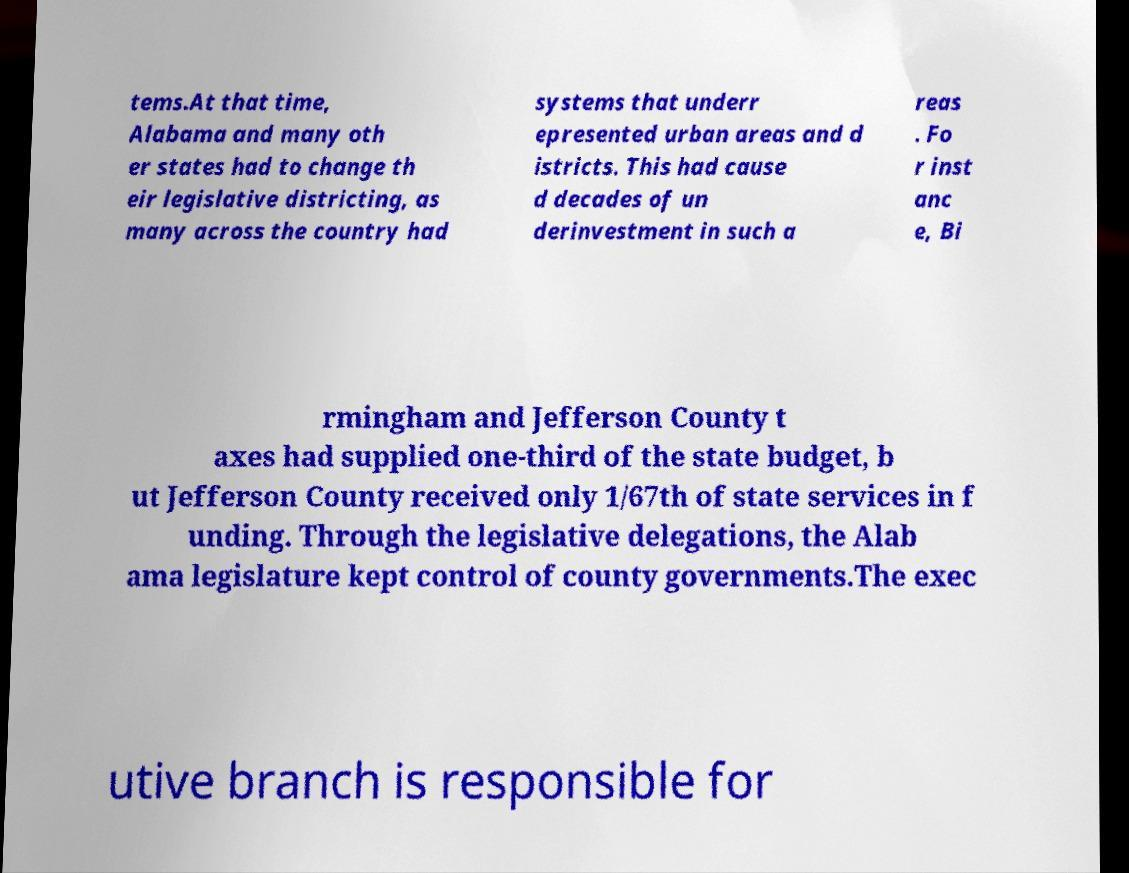For documentation purposes, I need the text within this image transcribed. Could you provide that? tems.At that time, Alabama and many oth er states had to change th eir legislative districting, as many across the country had systems that underr epresented urban areas and d istricts. This had cause d decades of un derinvestment in such a reas . Fo r inst anc e, Bi rmingham and Jefferson County t axes had supplied one-third of the state budget, b ut Jefferson County received only 1/67th of state services in f unding. Through the legislative delegations, the Alab ama legislature kept control of county governments.The exec utive branch is responsible for 